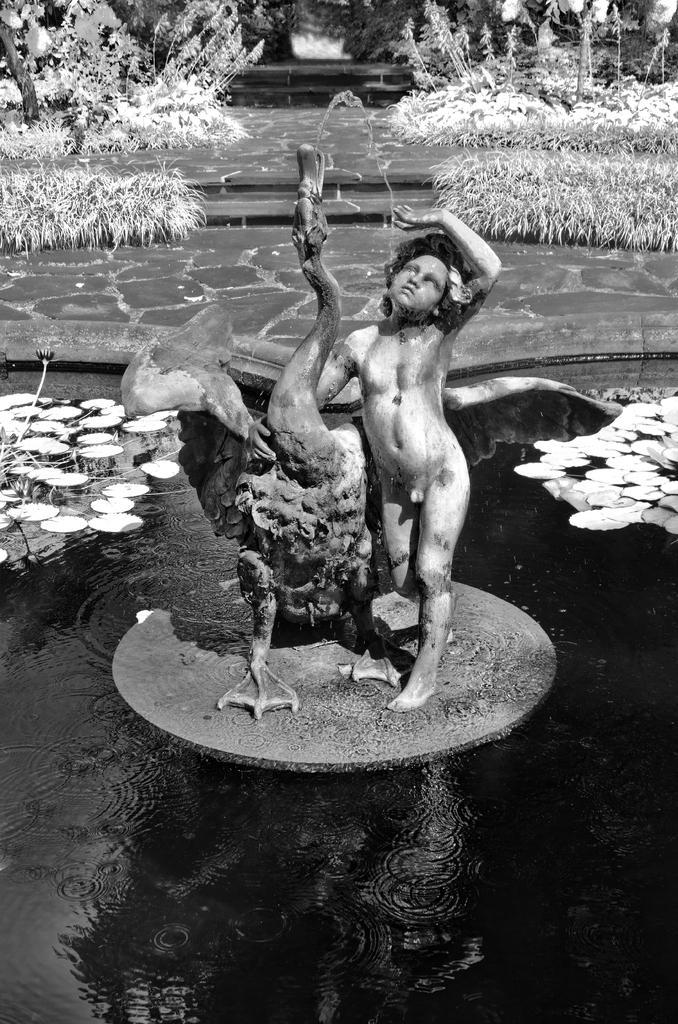How would you summarize this image in a sentence or two? This is a black and white image in this image in the center there is one statue and at the bottom there is one pond. In that pond there are some lotus flowers and leaves. In the background there are some plants and a walkway. 